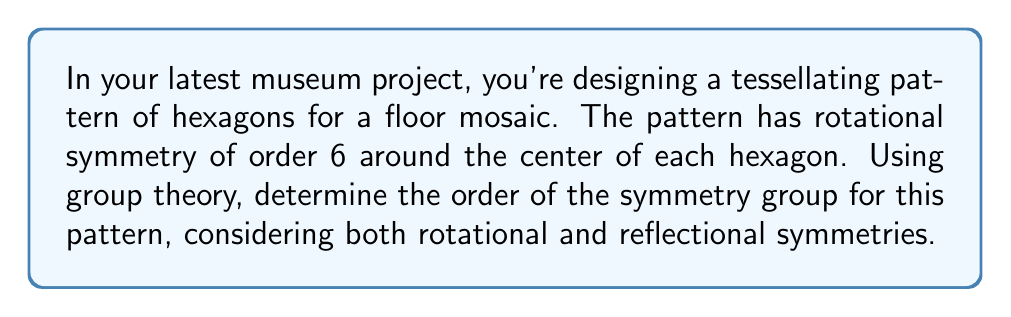Give your solution to this math problem. Let's approach this step-by-step using group theory:

1) First, let's identify the symmetries:
   - Rotational symmetry of order 6 (rotations by 60°, 120°, 180°, 240°, 300°, and 360°)
   - Reflection symmetry across 6 axes (through each vertex and the midpoint of each side)

2) The symmetry group of a regular hexagon is known as the dihedral group $D_6$.

3) The order of a dihedral group $D_n$ is given by the formula:

   $$|D_n| = 2n$$

   Where $n$ is the number of rotational symmetries.

4) In this case, $n = 6$, so:

   $$|D_6| = 2(6) = 12$$

5) We can verify this by counting the symmetries:
   - 6 rotational symmetries (including the identity rotation)
   - 6 reflection symmetries

6) The total number of symmetries is indeed 6 + 6 = 12.

7) Therefore, the order of the symmetry group for this hexagonal pattern is 12.

[asy]
unitsize(1cm);
for(int i=0; i<6; ++i) {
  draw(rotate(60*i)*((-1,0)--(-.5,0.866)--(0.5,0.866)--(1,0)--(0.5,-0.866)--(-.5,-0.866)--cycle));
}
for(int i=0; i<6; ++i) {
  draw(rotate(30+60*i)*((0,0)--(2,0)), dashed);
}
[/asy]

The diagram shows a hexagon with its 6 axes of reflection (dashed lines).
Answer: 12 